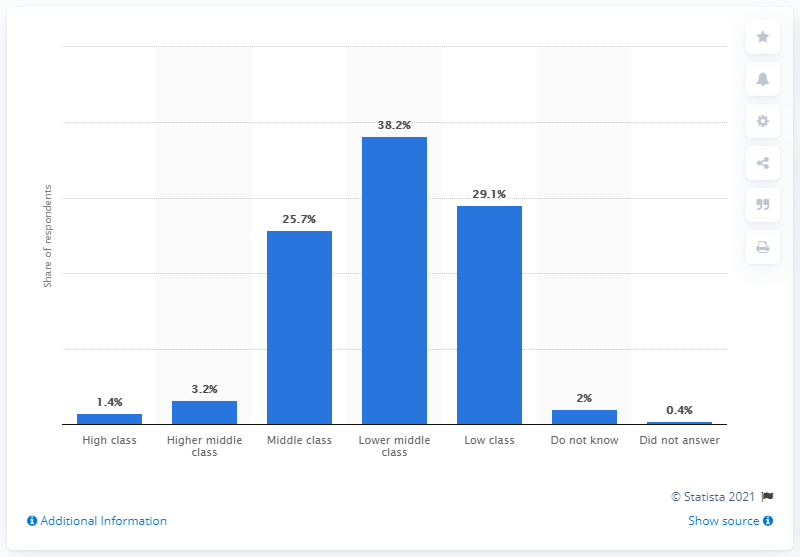Indicate a few pertinent items in this graphic. According to the results of a 2018 survey, 38.2% of respondents identified themselves as belonging to the lower middle class. 